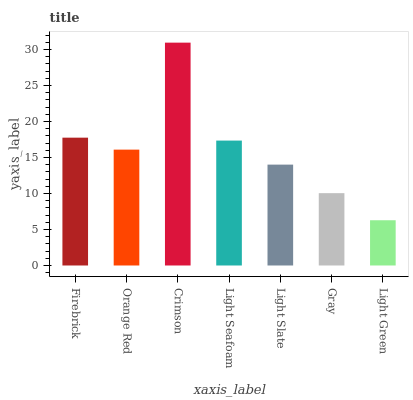Is Light Green the minimum?
Answer yes or no. Yes. Is Crimson the maximum?
Answer yes or no. Yes. Is Orange Red the minimum?
Answer yes or no. No. Is Orange Red the maximum?
Answer yes or no. No. Is Firebrick greater than Orange Red?
Answer yes or no. Yes. Is Orange Red less than Firebrick?
Answer yes or no. Yes. Is Orange Red greater than Firebrick?
Answer yes or no. No. Is Firebrick less than Orange Red?
Answer yes or no. No. Is Orange Red the high median?
Answer yes or no. Yes. Is Orange Red the low median?
Answer yes or no. Yes. Is Crimson the high median?
Answer yes or no. No. Is Light Slate the low median?
Answer yes or no. No. 